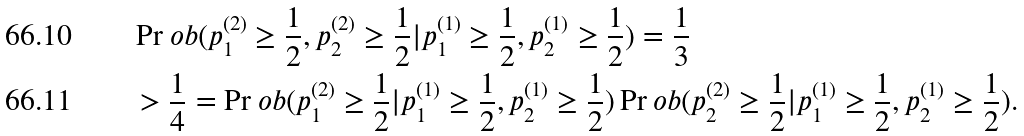<formula> <loc_0><loc_0><loc_500><loc_500>& \Pr o b ( p _ { 1 } ^ { ( 2 ) } \geq \frac { 1 } { 2 } , p _ { 2 } ^ { ( 2 ) } \geq \frac { 1 } { 2 } | p _ { 1 } ^ { ( 1 ) } \geq \frac { 1 } { 2 } , p _ { 2 } ^ { ( 1 ) } \geq \frac { 1 } { 2 } ) = \frac { 1 } { 3 } \\ & > \frac { 1 } { 4 } = \Pr o b ( p _ { 1 } ^ { ( 2 ) } \geq \frac { 1 } { 2 } | p _ { 1 } ^ { ( 1 ) } \geq \frac { 1 } { 2 } , p _ { 2 } ^ { ( 1 ) } \geq \frac { 1 } { 2 } ) \Pr o b ( p _ { 2 } ^ { ( 2 ) } \geq \frac { 1 } { 2 } | p _ { 1 } ^ { ( 1 ) } \geq \frac { 1 } { 2 } , p _ { 2 } ^ { ( 1 ) } \geq \frac { 1 } { 2 } ) .</formula> 